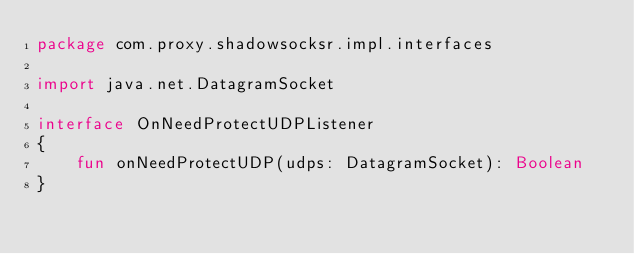<code> <loc_0><loc_0><loc_500><loc_500><_Kotlin_>package com.proxy.shadowsocksr.impl.interfaces

import java.net.DatagramSocket

interface OnNeedProtectUDPListener
{
    fun onNeedProtectUDP(udps: DatagramSocket): Boolean
}
</code> 